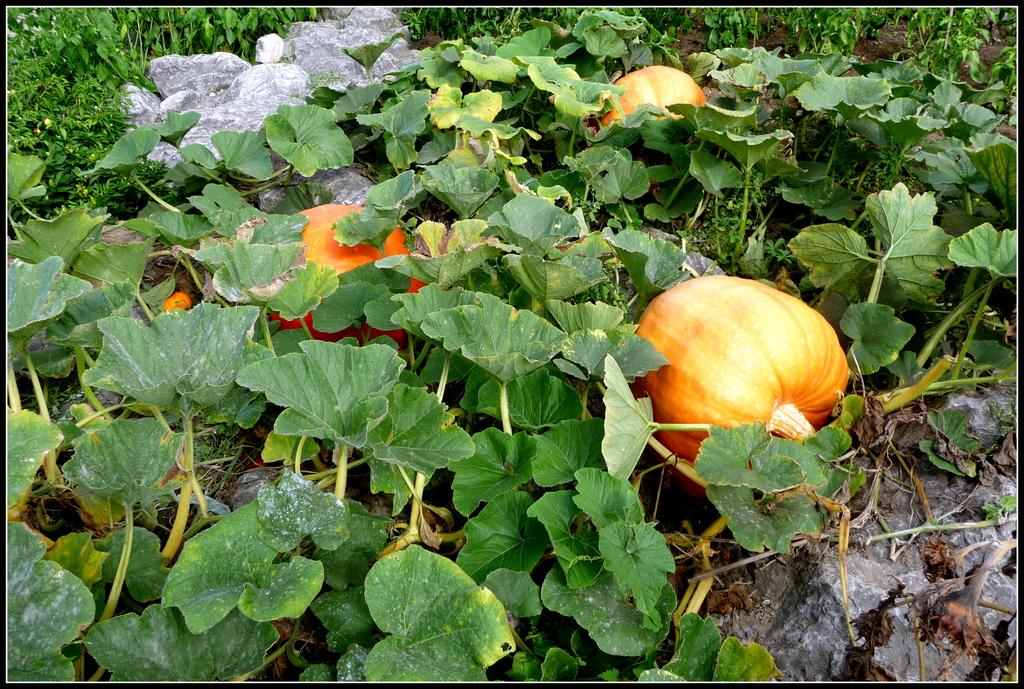What type of vegetation can be seen on the land in the image? There are pumpkins on the land in the image. What other objects can be seen on the land? There are stones visible in the image. Are there any living organisms present in the image? Yes, there are plants in the image. What type of love can be seen in the image? There is no love present in the image; it features pumpkins, stones, and plants. Can you describe the girl in the image? There is no girl present in the image. 